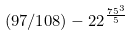Convert formula to latex. <formula><loc_0><loc_0><loc_500><loc_500>( 9 7 / 1 0 8 ) - 2 2 ^ { \frac { 7 5 ^ { 3 } } { 5 } }</formula> 